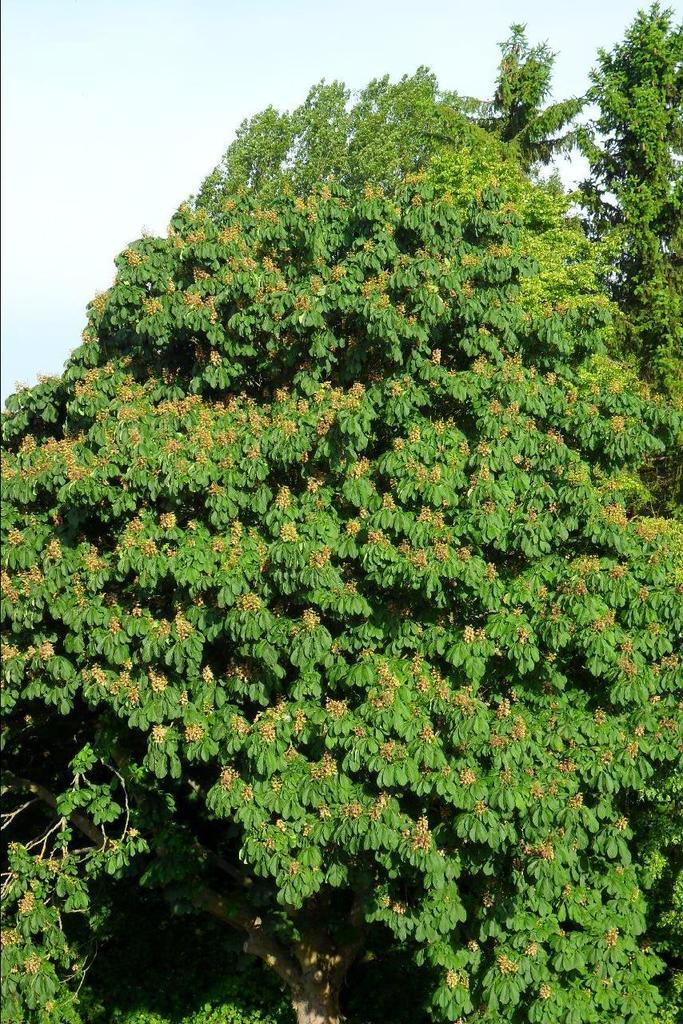What type of vegetation is present in the image? There is a tree in the image. What is visible at the top of the image? The sky is visible at the top of the image. What is the purpose of the patch on the tree in the image? There is no patch present on the tree in the image. 